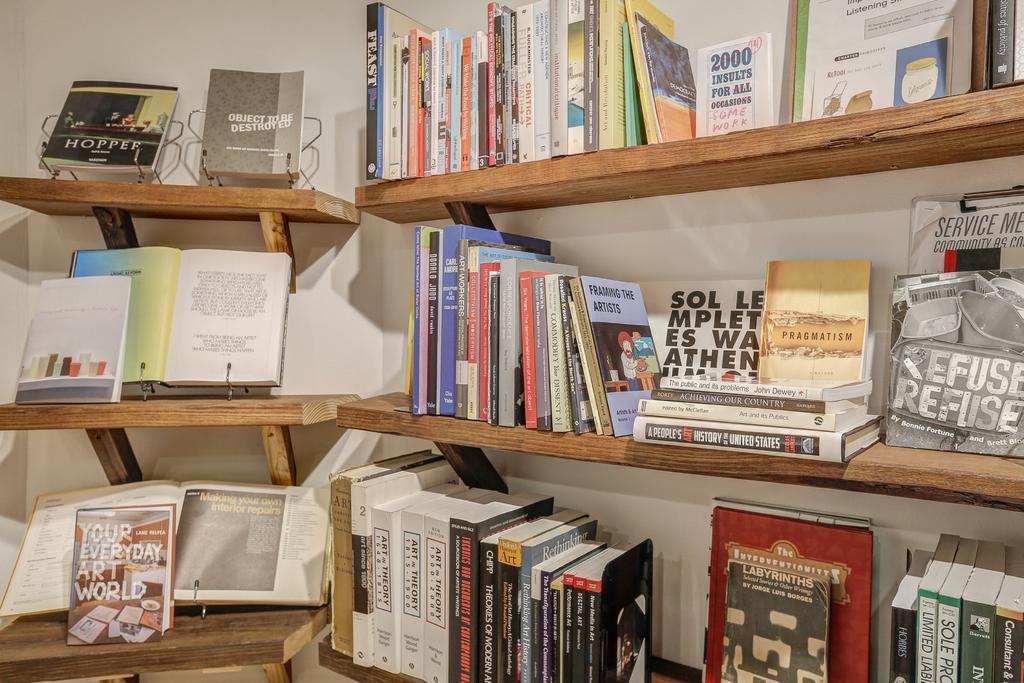Please provide a concise description of this image. The picture consists of books, in the bookshelves. In the background it is wall painted white. The bookshelves are made of wood. 